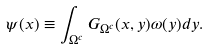Convert formula to latex. <formula><loc_0><loc_0><loc_500><loc_500>\psi ( x ) \equiv \int _ { \Omega ^ { c } } G _ { \Omega ^ { c } } ( x , y ) \omega ( y ) d y .</formula> 